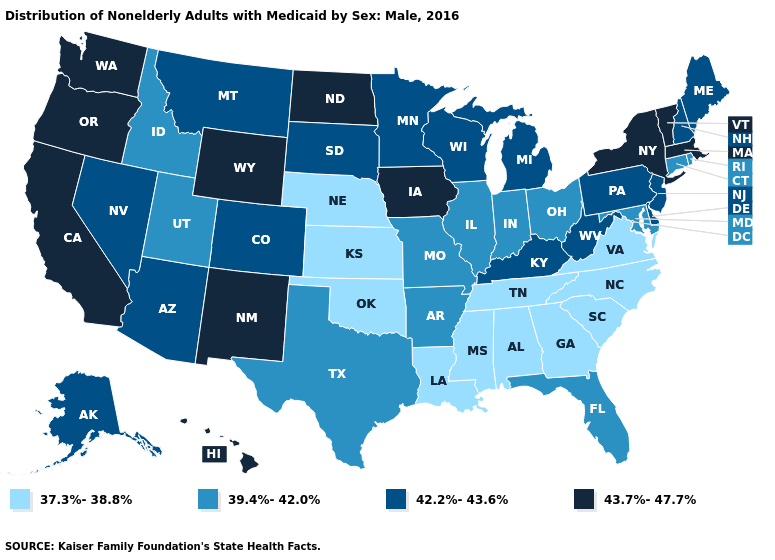Name the states that have a value in the range 37.3%-38.8%?
Short answer required. Alabama, Georgia, Kansas, Louisiana, Mississippi, Nebraska, North Carolina, Oklahoma, South Carolina, Tennessee, Virginia. What is the value of Utah?
Answer briefly. 39.4%-42.0%. Is the legend a continuous bar?
Give a very brief answer. No. Which states have the lowest value in the USA?
Write a very short answer. Alabama, Georgia, Kansas, Louisiana, Mississippi, Nebraska, North Carolina, Oklahoma, South Carolina, Tennessee, Virginia. Name the states that have a value in the range 43.7%-47.7%?
Short answer required. California, Hawaii, Iowa, Massachusetts, New Mexico, New York, North Dakota, Oregon, Vermont, Washington, Wyoming. Does Vermont have the lowest value in the Northeast?
Write a very short answer. No. Which states have the highest value in the USA?
Quick response, please. California, Hawaii, Iowa, Massachusetts, New Mexico, New York, North Dakota, Oregon, Vermont, Washington, Wyoming. Among the states that border Pennsylvania , does New York have the highest value?
Concise answer only. Yes. What is the highest value in states that border Missouri?
Give a very brief answer. 43.7%-47.7%. Name the states that have a value in the range 37.3%-38.8%?
Answer briefly. Alabama, Georgia, Kansas, Louisiana, Mississippi, Nebraska, North Carolina, Oklahoma, South Carolina, Tennessee, Virginia. Name the states that have a value in the range 43.7%-47.7%?
Answer briefly. California, Hawaii, Iowa, Massachusetts, New Mexico, New York, North Dakota, Oregon, Vermont, Washington, Wyoming. Name the states that have a value in the range 37.3%-38.8%?
Give a very brief answer. Alabama, Georgia, Kansas, Louisiana, Mississippi, Nebraska, North Carolina, Oklahoma, South Carolina, Tennessee, Virginia. Does Louisiana have the lowest value in the USA?
Quick response, please. Yes. Name the states that have a value in the range 37.3%-38.8%?
Be succinct. Alabama, Georgia, Kansas, Louisiana, Mississippi, Nebraska, North Carolina, Oklahoma, South Carolina, Tennessee, Virginia. Does Maine have the lowest value in the USA?
Be succinct. No. 